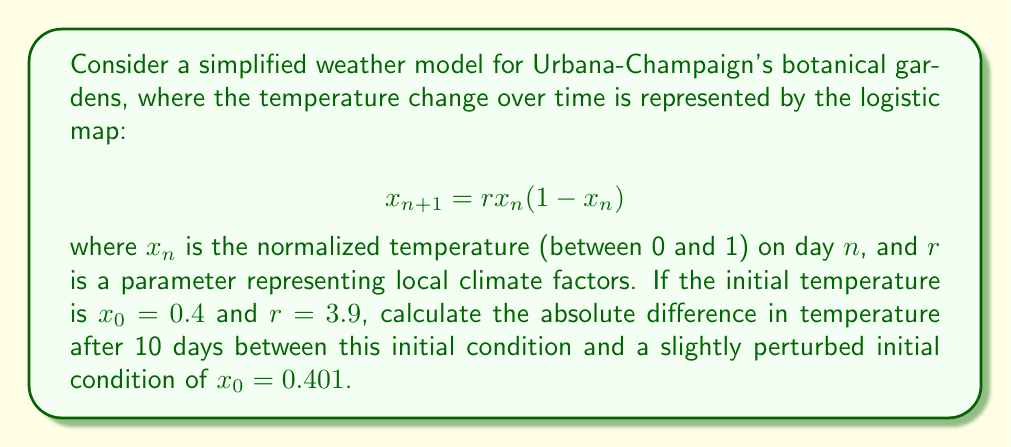Could you help me with this problem? 1) First, we need to iterate the logistic map for both initial conditions:

   For $x_0 = 0.4$:
   $x_1 = 3.9 * 0.4 * (1-0.4) = 0.936$
   $x_2 = 3.9 * 0.936 * (1-0.936) = 0.234144$
   ...continue until $x_{10}$

   For $x_0 = 0.401$:
   $x_1 = 3.9 * 0.401 * (1-0.401) = 0.936381$
   $x_2 = 3.9 * 0.936381 * (1-0.936381) = 0.232872$
   ...continue until $x_{10}$

2) We can use a calculator or computer program to iterate quickly. After 10 iterations:

   For $x_0 = 0.4$: $x_{10} \approx 0.621944$
   For $x_0 = 0.401$: $x_{10} \approx 0.826015$

3) The absolute difference is:
   $|0.621944 - 0.826015| \approx 0.204071$

This significant difference from a tiny change in initial conditions demonstrates the butterfly effect in chaotic systems, relevant to local weather patterns affecting botanical gardens.
Answer: 0.204071 